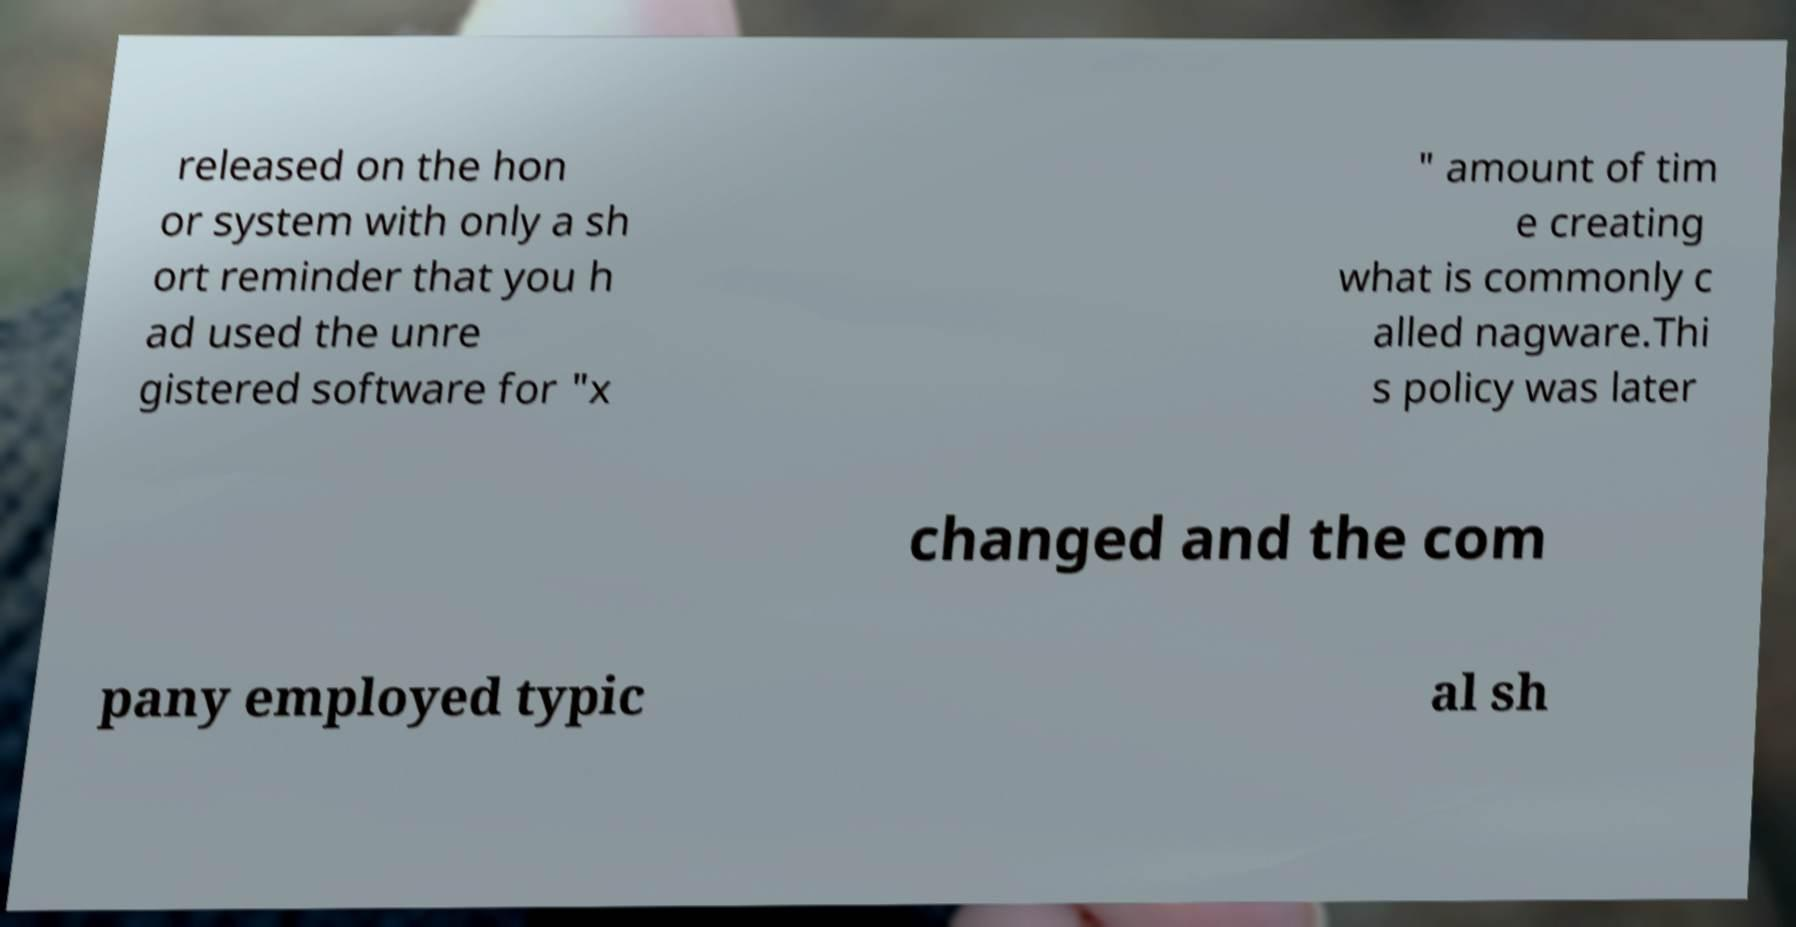I need the written content from this picture converted into text. Can you do that? released on the hon or system with only a sh ort reminder that you h ad used the unre gistered software for "x " amount of tim e creating what is commonly c alled nagware.Thi s policy was later changed and the com pany employed typic al sh 